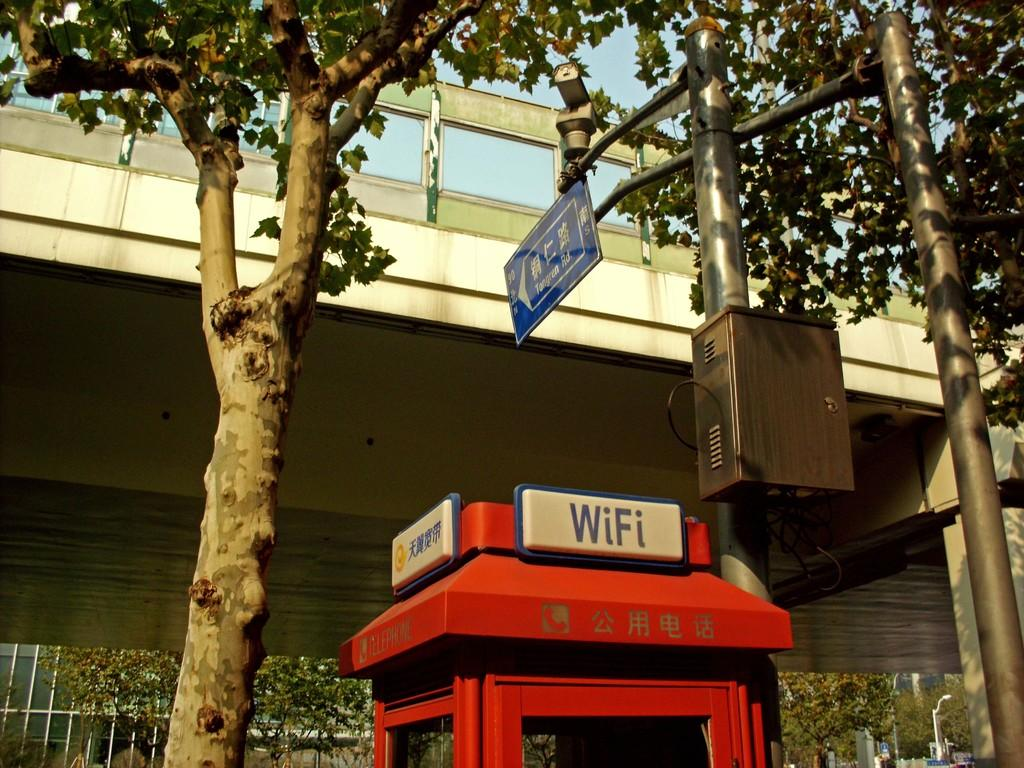<image>
Provide a brief description of the given image. a telephone box that has a sign on the top that says 'wifi' on it 